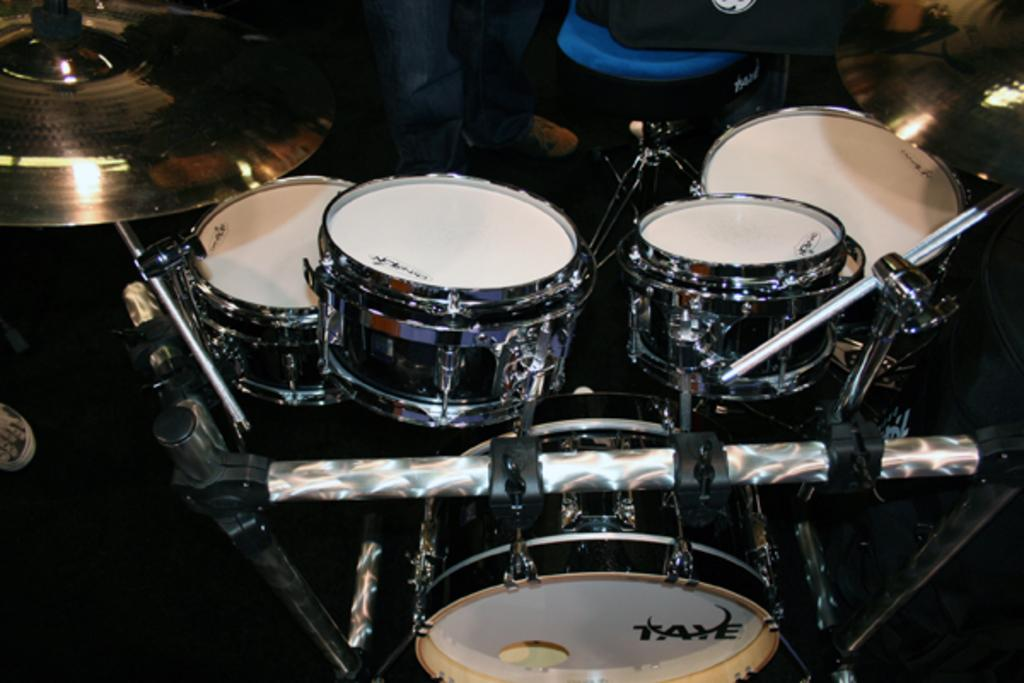What musical instrument is present in the image? There is a drum in the image. What device is used for amplifying sound in the image? There is a microphone (mic) in the image. What is the person standing near in the image? The person is standing near a chair. What type of clothing is the person wearing on their legs? The person is wearing jeans. What type of footwear is the person wearing? The person is wearing shoes. How many horses are present in the image? There are no horses present in the image. Who is the owner of the drum in the image? There is no information about the ownership of the drum in the image. 